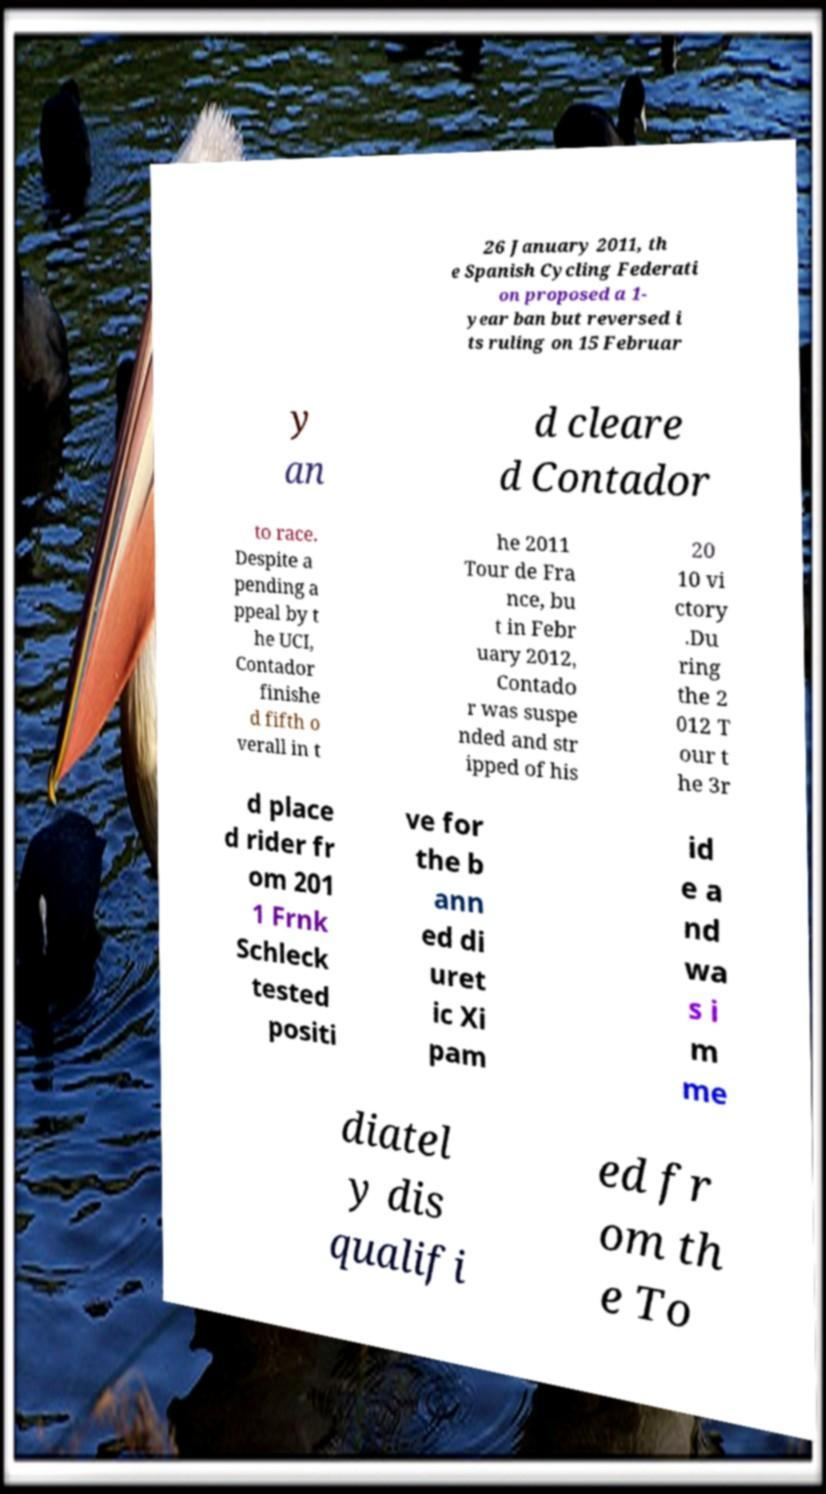Could you extract and type out the text from this image? 26 January 2011, th e Spanish Cycling Federati on proposed a 1- year ban but reversed i ts ruling on 15 Februar y an d cleare d Contador to race. Despite a pending a ppeal by t he UCI, Contador finishe d fifth o verall in t he 2011 Tour de Fra nce, bu t in Febr uary 2012, Contado r was suspe nded and str ipped of his 20 10 vi ctory .Du ring the 2 012 T our t he 3r d place d rider fr om 201 1 Frnk Schleck tested positi ve for the b ann ed di uret ic Xi pam id e a nd wa s i m me diatel y dis qualifi ed fr om th e To 